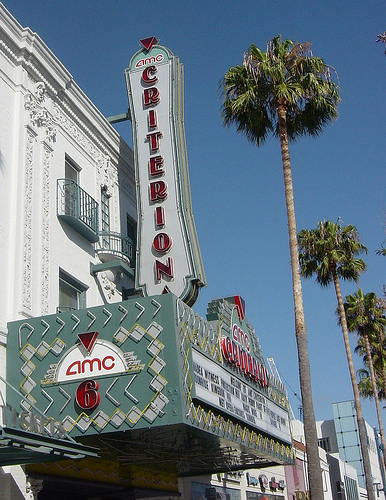<image>
Is the board in front of the building? Yes. The board is positioned in front of the building, appearing closer to the camera viewpoint. 